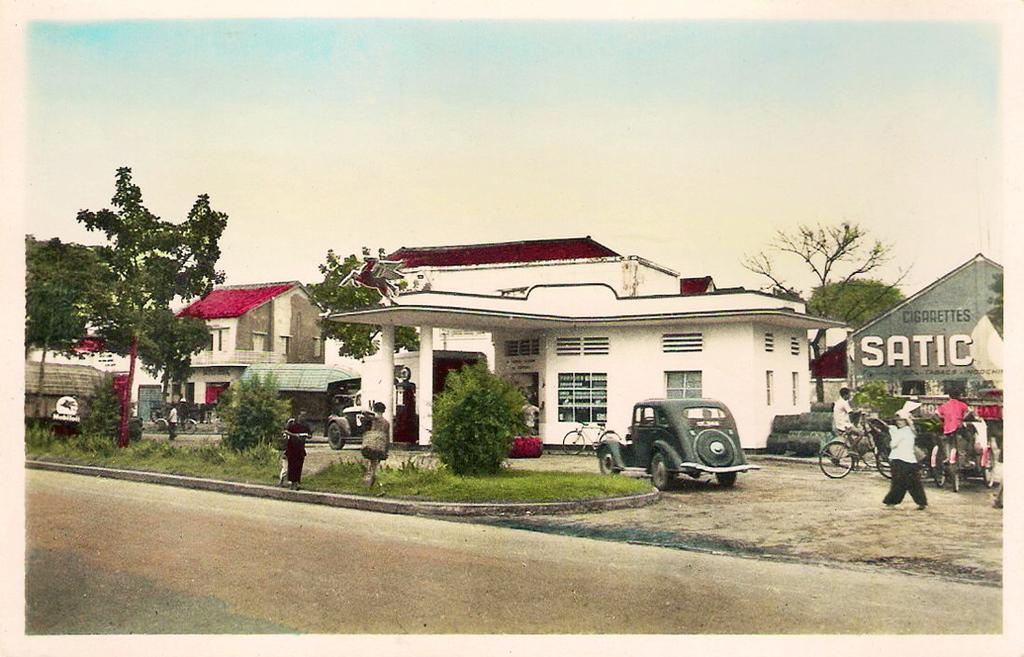What type of structures are visible in the image? There are houses in the image. Can you describe the scene in front of the houses? There is a person, plants, trees, and vehicles in front of the houses. What is visible at the top of the image? The sky is visible at the top of the image. What type of jar can be seen hanging from the wire in the image? There is no jar or wire present in the image. Can you describe the coastline visible in the image? There is no coastline visible in the image; it features houses, a person, plants, trees, vehicles, and the sky. 